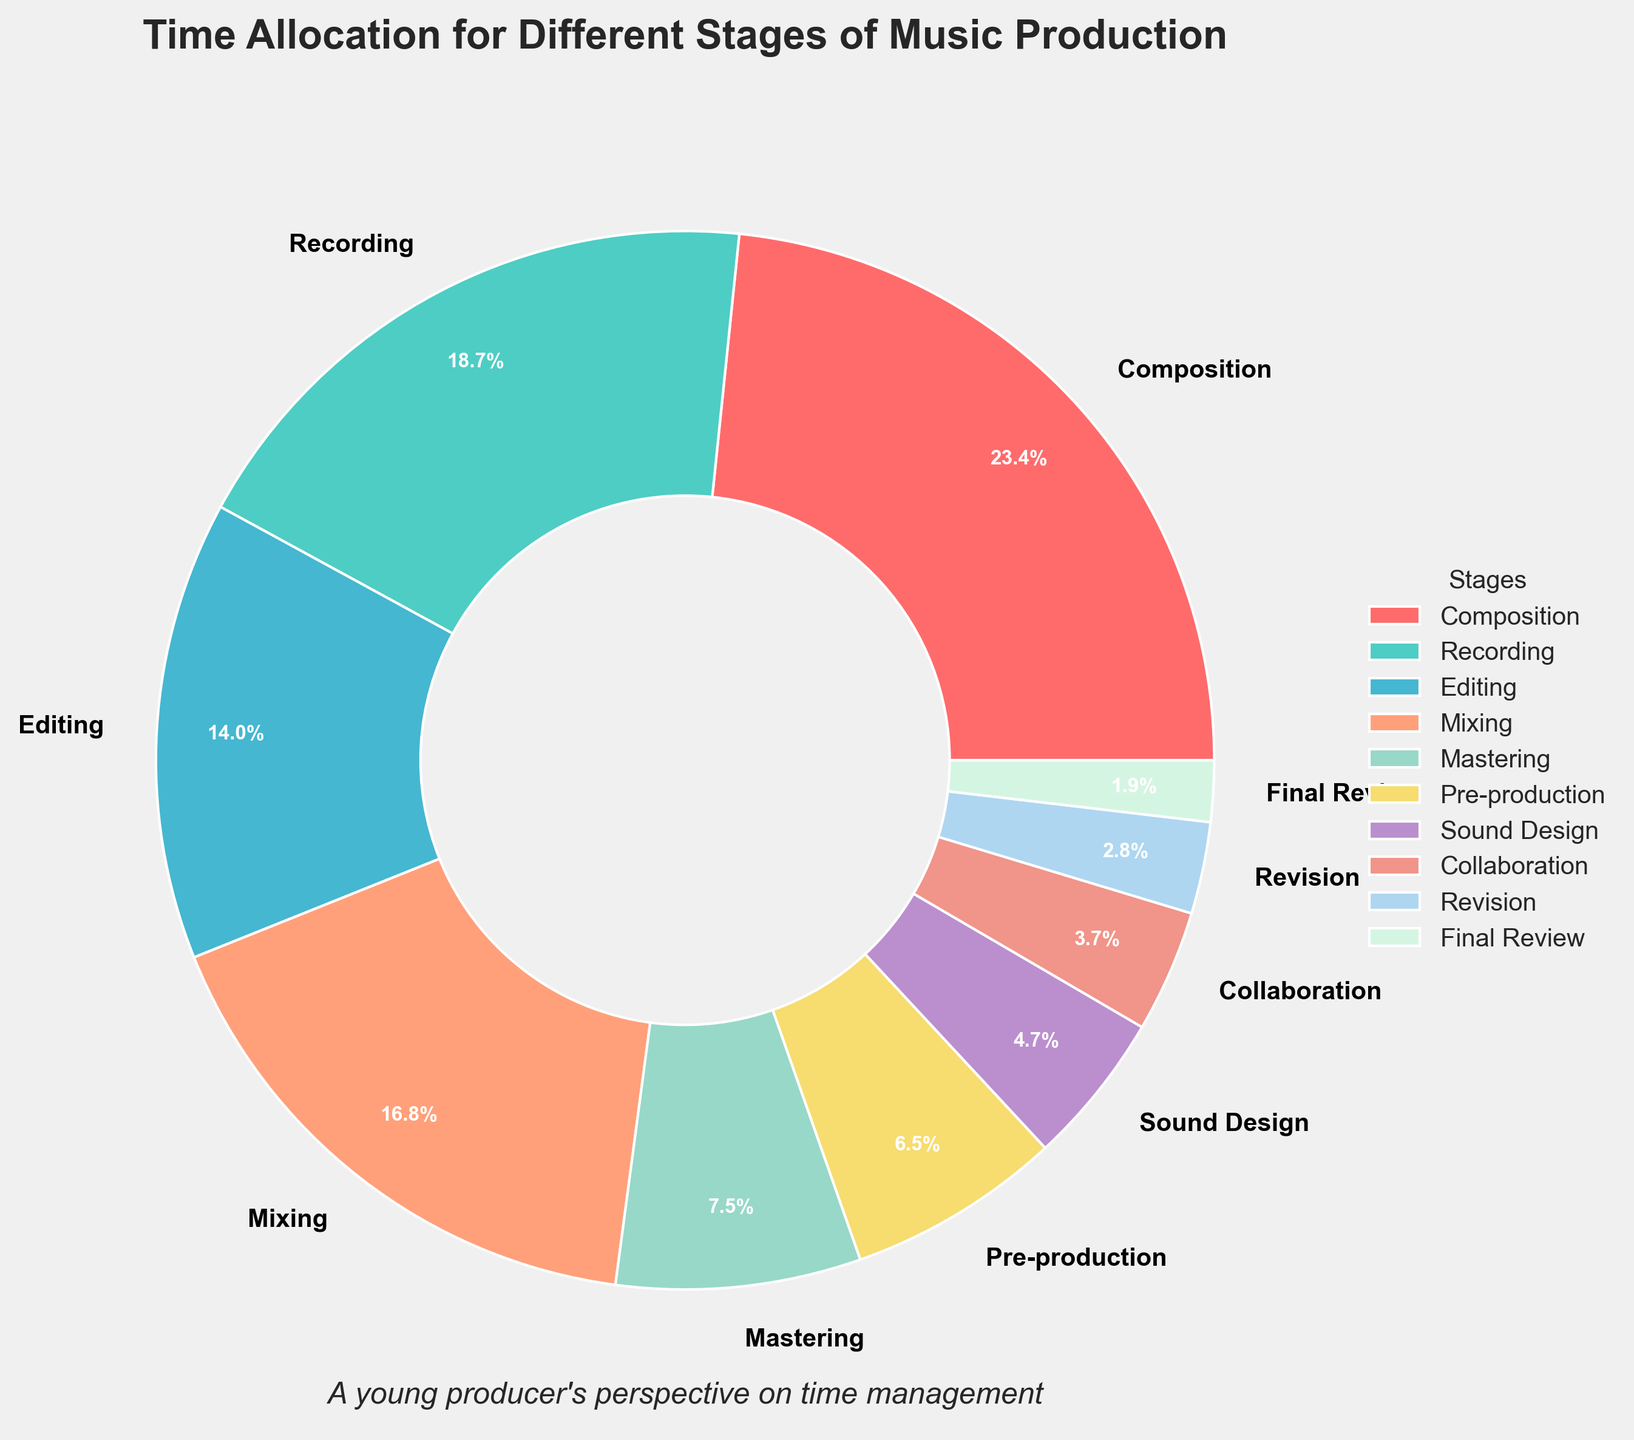What's the total percentage of time spent on Composition, Recording, and Mixing combined? The given percentages for Composition, Recording, and Mixing are 25%, 20%, and 18% respectively. Adding these up: 25 + 20 + 18 = 63.
Answer: 63% Which stage allocates more time: Pre-production or Sound Design? The percentage for Pre-production is 7%, while Sound Design allocates 5%. Since 7 is greater than 5, Pre-production allocates more time than Sound Design.
Answer: Pre-production What is the second least time-consuming stage? The figure shows the percentages, and we see the smallest is Final Review at 2%. The next smallest is Revision at 3%. Therefore, the second least time-consuming stage is Revision.
Answer: Revision Which stages together account for more than 50% of the total time? Adding the largest percentages until the sum exceeds 50: Composition (25%), Recording (20%), and Mixing (18%) total 25 + 20 + 18 = 63, which is more than 50%. These stages account for more than 50% of the total time.
Answer: Composition, Recording, Mixing What is the average percentage of time spent on Editing, Mastering, and Collaboration? The percentages are 15% (Editing), 8% (Mastering), and 4% (Collaboration). The total is 15 + 8 + 4 = 27. The average is 27 / 3 = 9.
Answer: 9% Which stage is represented by the green segment in the pie chart? According to the custom color selection, Sound Design is represented by green.
Answer: Sound Design Is more time spent on Mixing or Mastering? Checking the percentages, Mixing is 18% while Mastering is 8%. Since 18 is greater than 8, more time is spent on Mixing.
Answer: Mixing How much more time is spent on Recording compared to Final Review? The percentage for Recording is 20% while for Final Review it is 2%. The difference is 20 - 2 = 18.
Answer: 18% Which stage allocates an equal percentage of time as the combined time of Final Review and Revision? The percentages are: Final Review (2%) + Revision (3%) = 5%. The stage with a 5% allocation is Sound Design.
Answer: Sound Design What fraction of the total time is spent on Collaboration? The total time is 100%. The percentage spent on Collaboration is 4%, which as a fraction of 100 is 4/100 or 1/25.
Answer: 1/25 